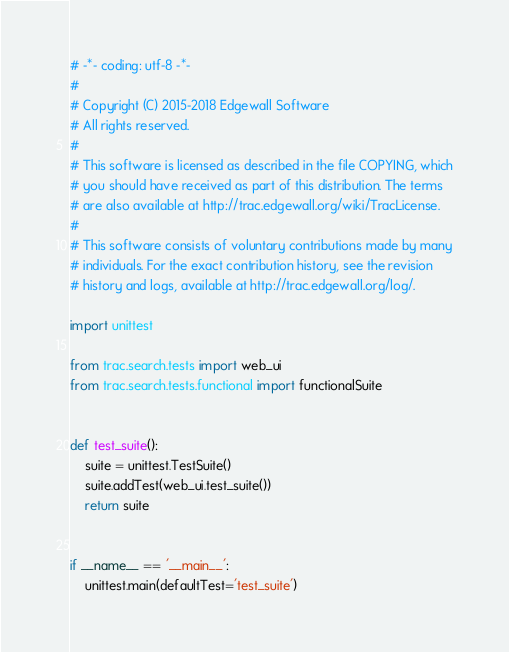<code> <loc_0><loc_0><loc_500><loc_500><_Python_># -*- coding: utf-8 -*-
#
# Copyright (C) 2015-2018 Edgewall Software
# All rights reserved.
#
# This software is licensed as described in the file COPYING, which
# you should have received as part of this distribution. The terms
# are also available at http://trac.edgewall.org/wiki/TracLicense.
#
# This software consists of voluntary contributions made by many
# individuals. For the exact contribution history, see the revision
# history and logs, available at http://trac.edgewall.org/log/.

import unittest

from trac.search.tests import web_ui
from trac.search.tests.functional import functionalSuite


def test_suite():
    suite = unittest.TestSuite()
    suite.addTest(web_ui.test_suite())
    return suite


if __name__ == '__main__':
    unittest.main(defaultTest='test_suite')
</code> 